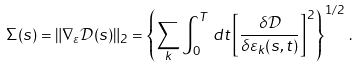<formula> <loc_0><loc_0><loc_500><loc_500>\Sigma ( s ) = \| \nabla _ { \varepsilon } \mathcal { D } ( s ) \| _ { 2 } = \left \{ \sum _ { k } \int _ { 0 } ^ { T } \, d t \left [ \frac { \delta \mathcal { D } } { \delta \varepsilon _ { k } ( s , t ) } \right ] ^ { 2 } \right \} ^ { 1 / 2 } \, .</formula> 